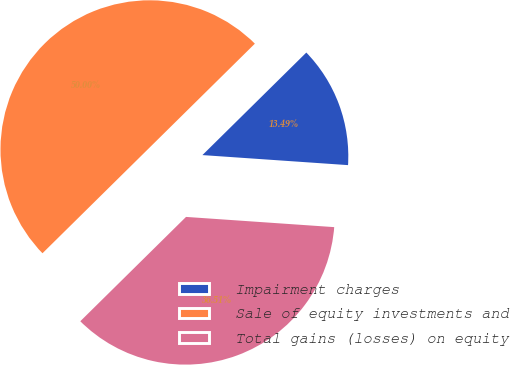Convert chart. <chart><loc_0><loc_0><loc_500><loc_500><pie_chart><fcel>Impairment charges<fcel>Sale of equity investments and<fcel>Total gains (losses) on equity<nl><fcel>13.49%<fcel>50.0%<fcel>36.51%<nl></chart> 